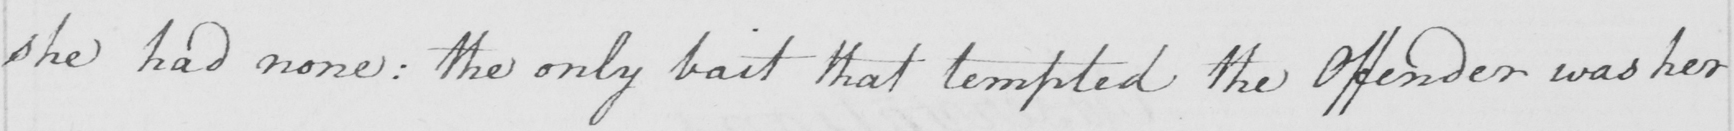Can you tell me what this handwritten text says? she had none :  the only bait that tempted the Offender was her 